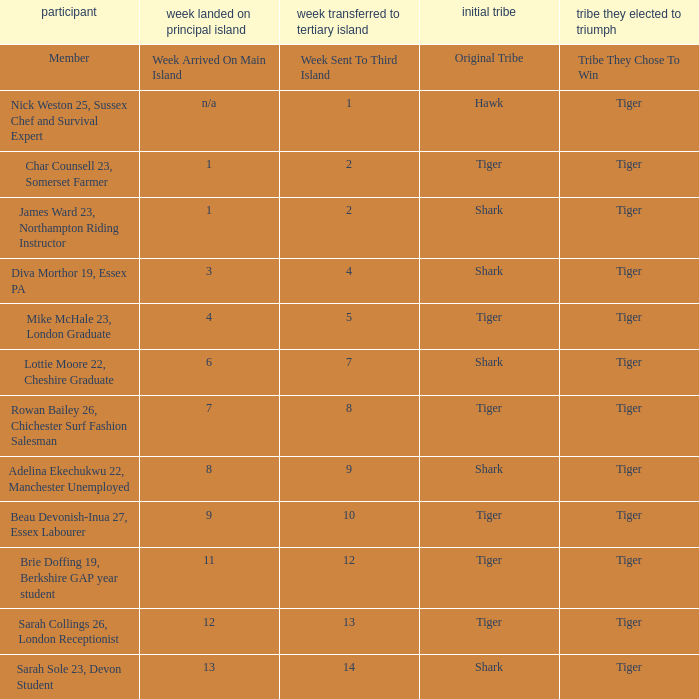What week was the member who arrived on the main island in week 6 sent to the third island? 7.0. 